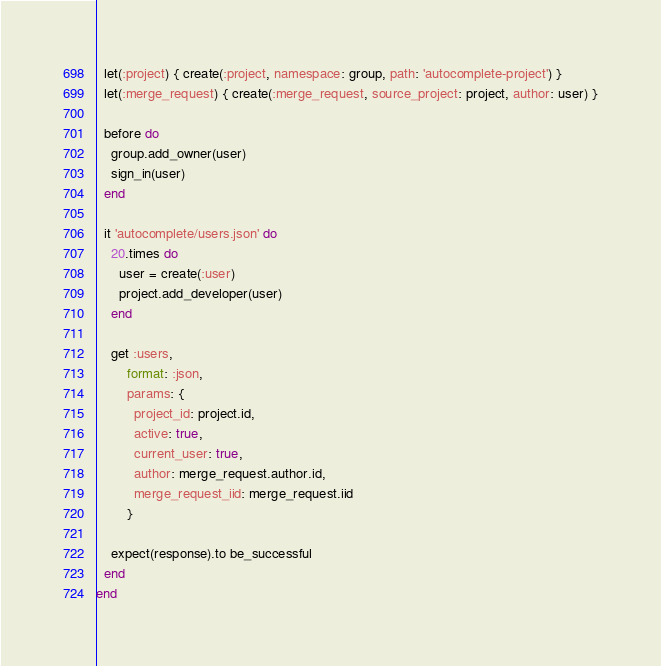<code> <loc_0><loc_0><loc_500><loc_500><_Ruby_>  let(:project) { create(:project, namespace: group, path: 'autocomplete-project') }
  let(:merge_request) { create(:merge_request, source_project: project, author: user) }

  before do
    group.add_owner(user)
    sign_in(user)
  end

  it 'autocomplete/users.json' do
    20.times do
      user = create(:user)
      project.add_developer(user)
    end

    get :users,
        format: :json,
        params: {
          project_id: project.id,
          active: true,
          current_user: true,
          author: merge_request.author.id,
          merge_request_iid: merge_request.iid
        }

    expect(response).to be_successful
  end
end
</code> 